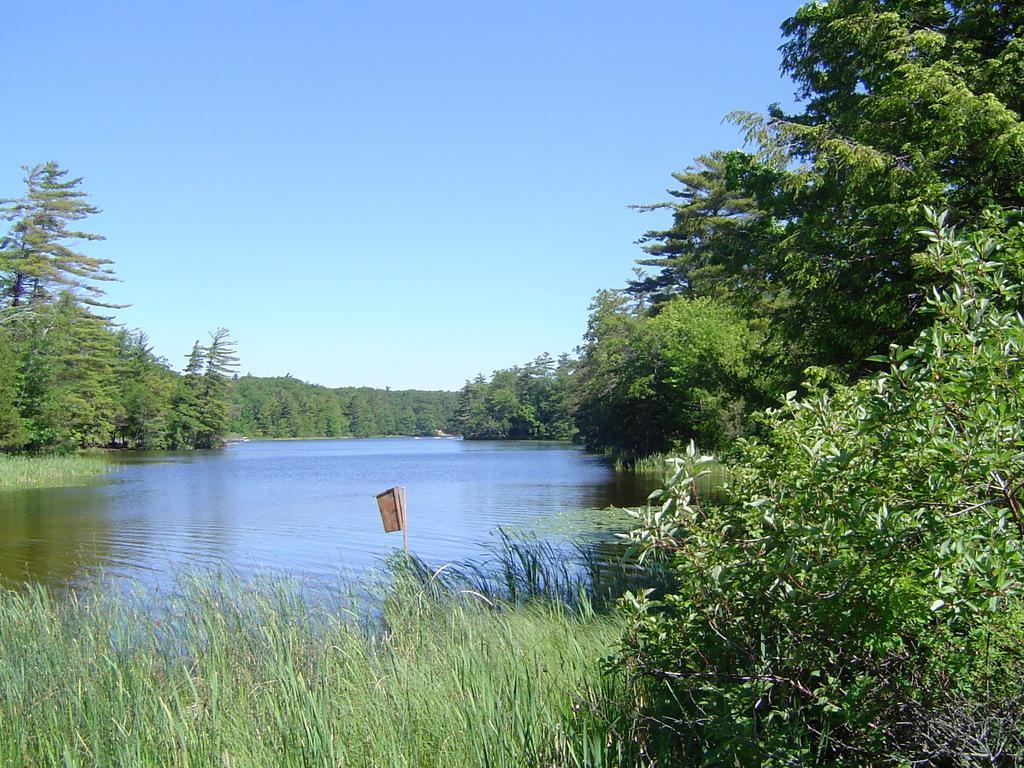In one or two sentences, can you explain what this image depicts? In this image we can see the lake. There are many trees and plants. There is an object in the image. We can see the sky in the image. 